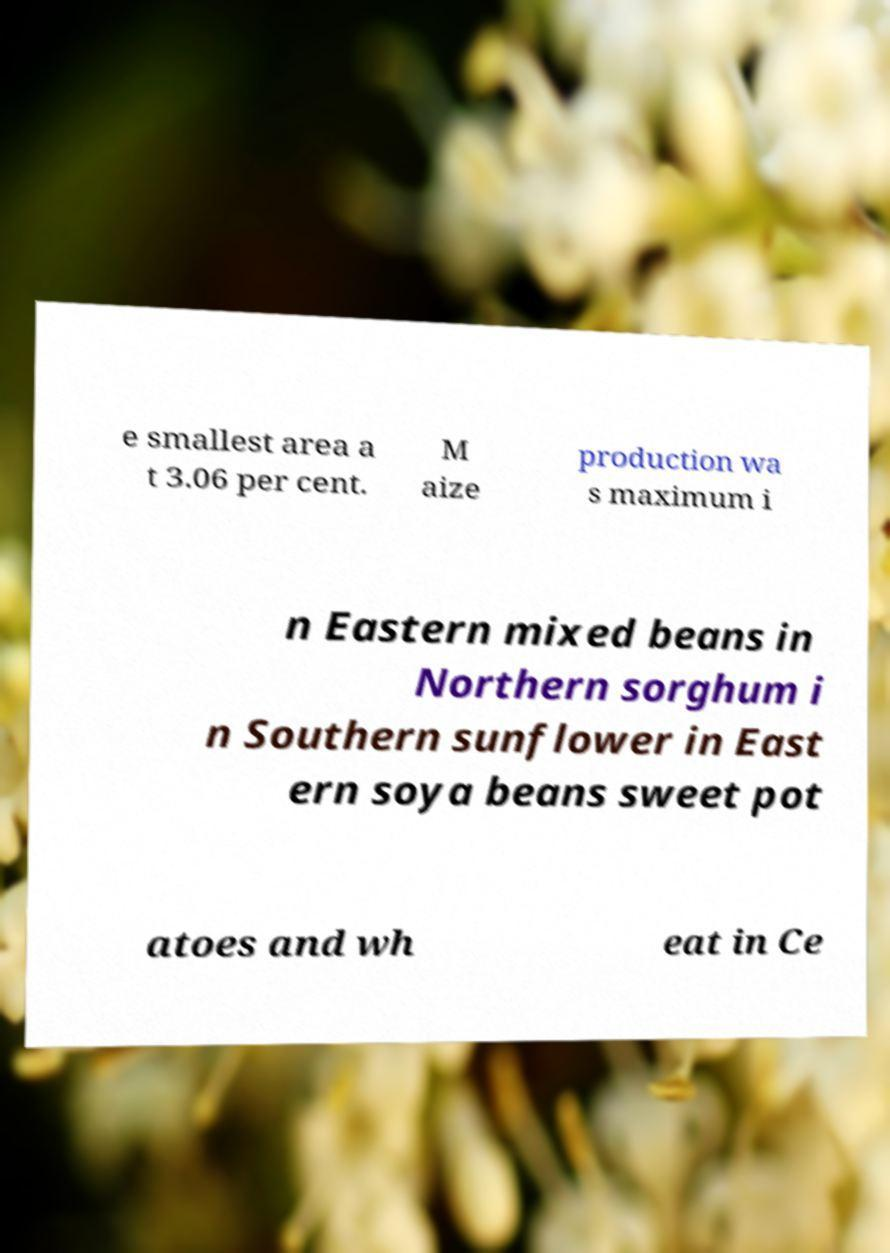Can you accurately transcribe the text from the provided image for me? e smallest area a t 3.06 per cent. M aize production wa s maximum i n Eastern mixed beans in Northern sorghum i n Southern sunflower in East ern soya beans sweet pot atoes and wh eat in Ce 